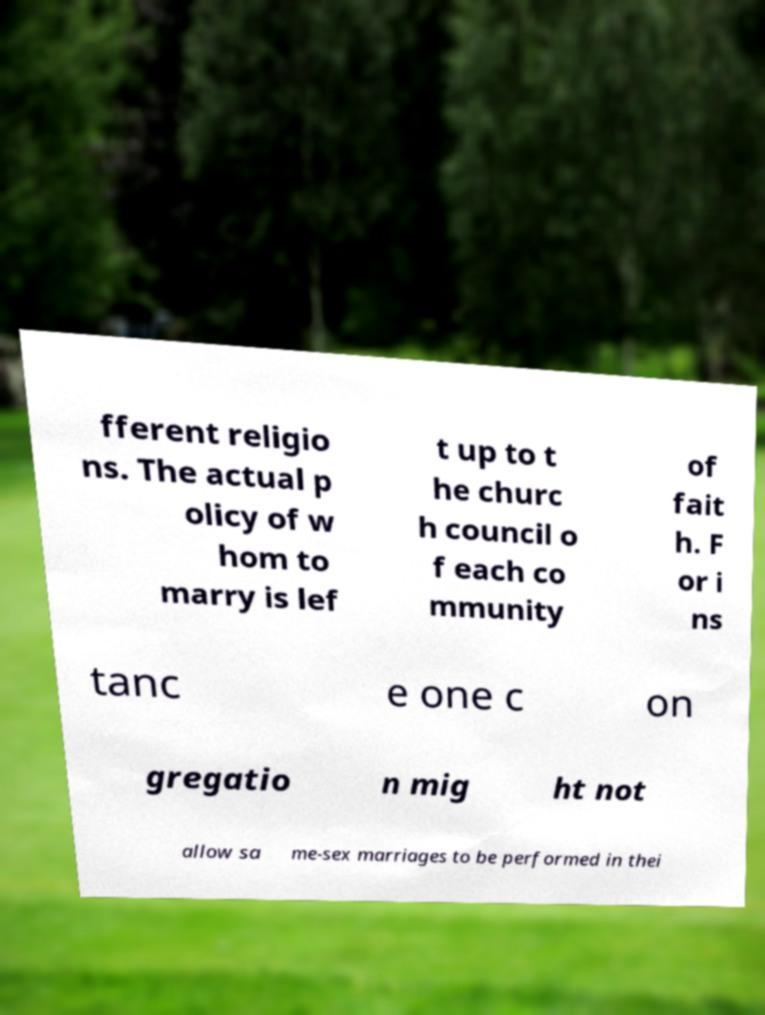There's text embedded in this image that I need extracted. Can you transcribe it verbatim? fferent religio ns. The actual p olicy of w hom to marry is lef t up to t he churc h council o f each co mmunity of fait h. F or i ns tanc e one c on gregatio n mig ht not allow sa me-sex marriages to be performed in thei 